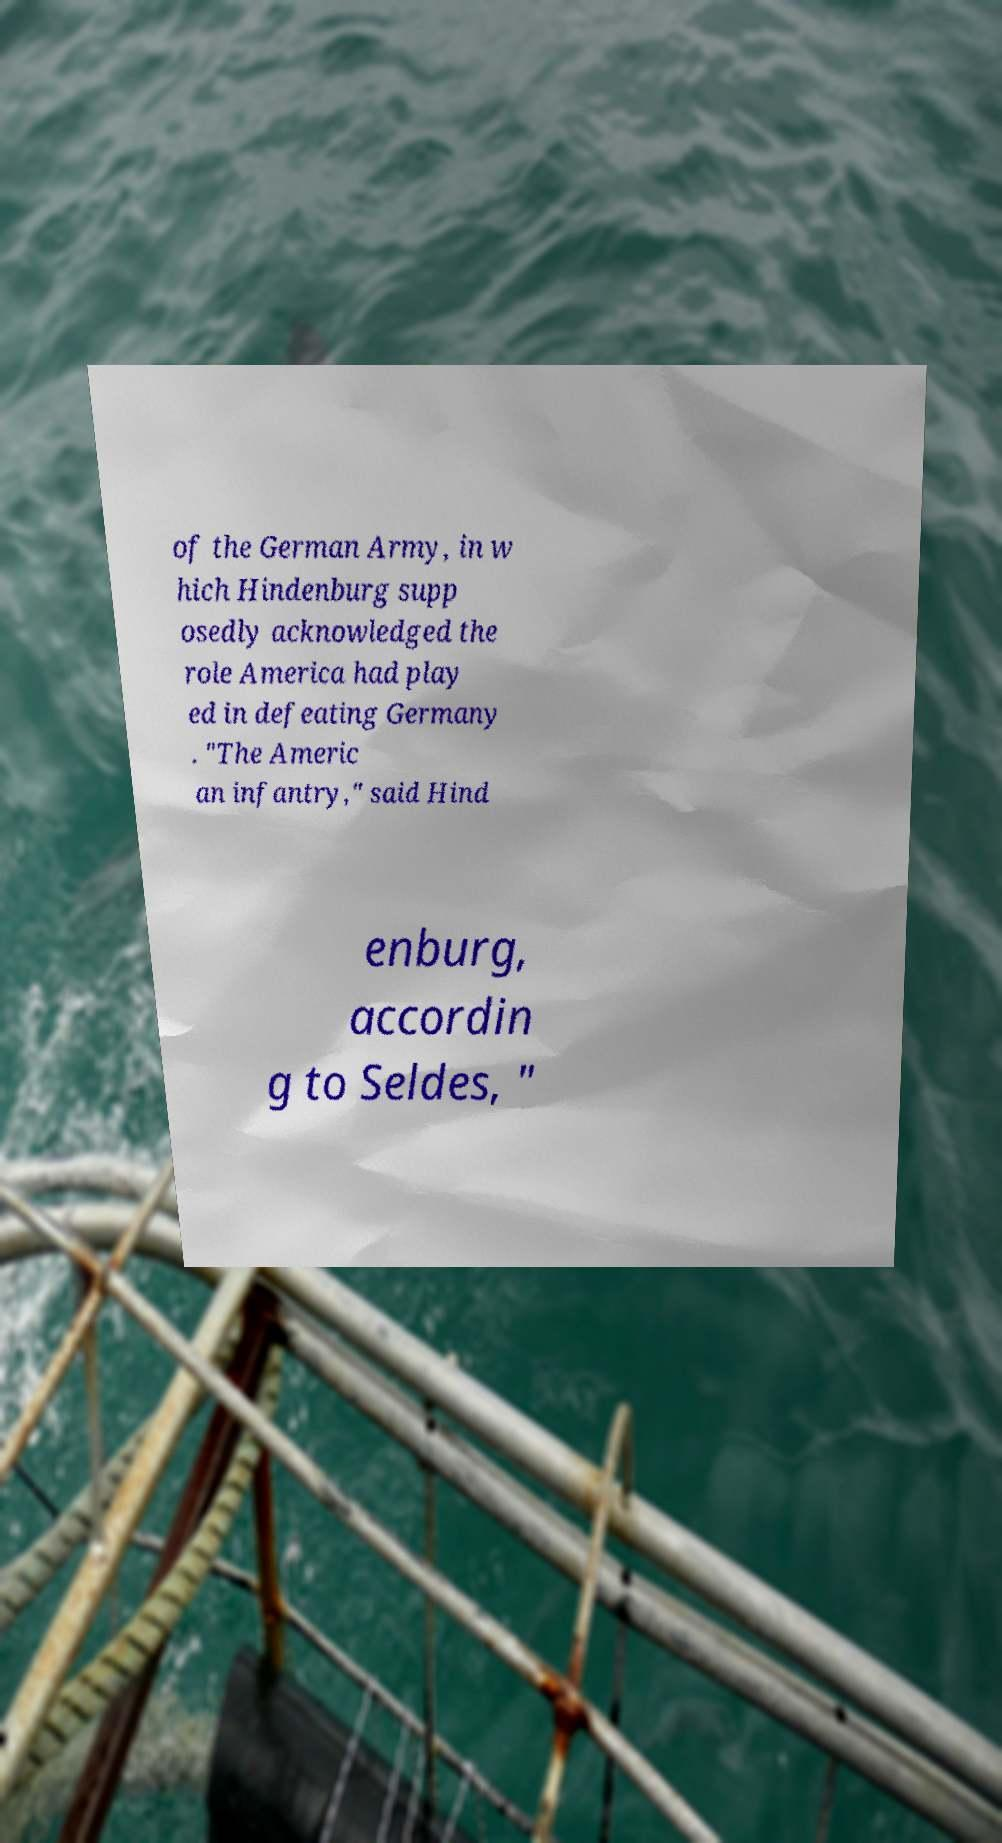For documentation purposes, I need the text within this image transcribed. Could you provide that? of the German Army, in w hich Hindenburg supp osedly acknowledged the role America had play ed in defeating Germany . "The Americ an infantry," said Hind enburg, accordin g to Seldes, " 